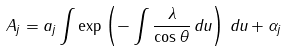Convert formula to latex. <formula><loc_0><loc_0><loc_500><loc_500>A _ { j } = a _ { j } \int \exp \left ( - \int \frac { \lambda } { \cos \theta } \, d u \right ) \, d u + \alpha _ { j }</formula> 